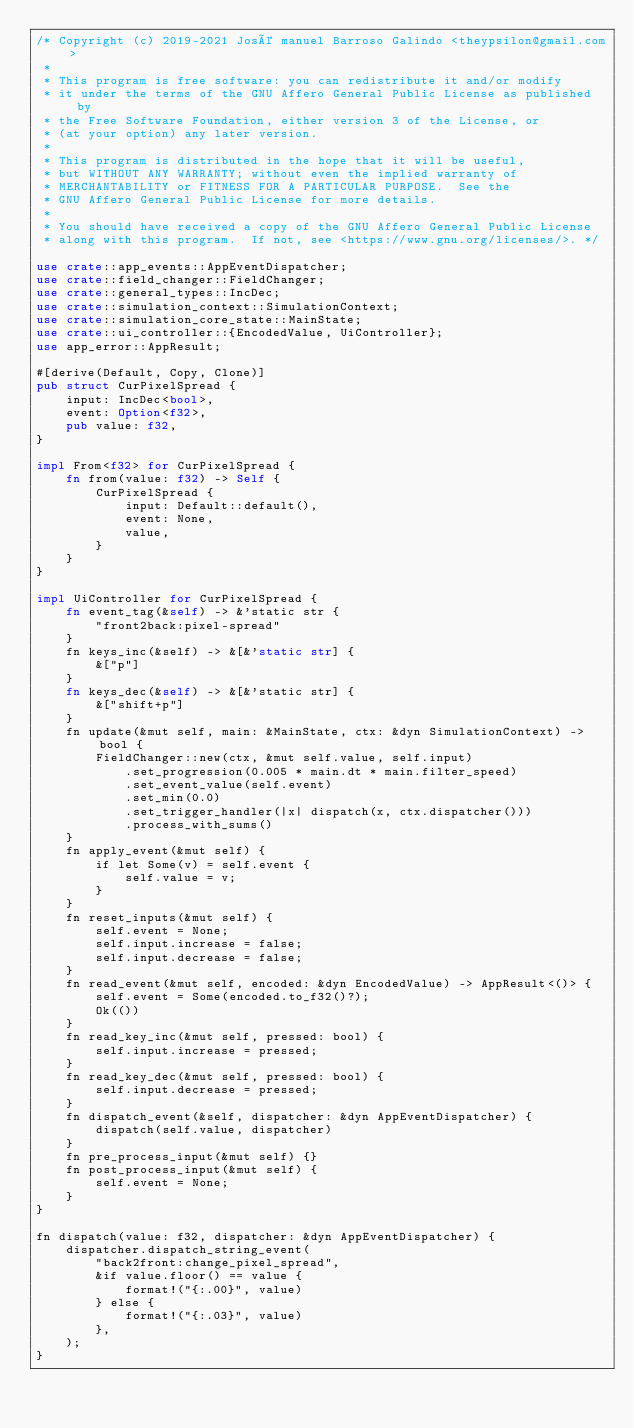Convert code to text. <code><loc_0><loc_0><loc_500><loc_500><_Rust_>/* Copyright (c) 2019-2021 José manuel Barroso Galindo <theypsilon@gmail.com>
 *
 * This program is free software: you can redistribute it and/or modify
 * it under the terms of the GNU Affero General Public License as published by
 * the Free Software Foundation, either version 3 of the License, or
 * (at your option) any later version.
 *
 * This program is distributed in the hope that it will be useful,
 * but WITHOUT ANY WARRANTY; without even the implied warranty of
 * MERCHANTABILITY or FITNESS FOR A PARTICULAR PURPOSE.  See the
 * GNU Affero General Public License for more details.
 *
 * You should have received a copy of the GNU Affero General Public License
 * along with this program.  If not, see <https://www.gnu.org/licenses/>. */

use crate::app_events::AppEventDispatcher;
use crate::field_changer::FieldChanger;
use crate::general_types::IncDec;
use crate::simulation_context::SimulationContext;
use crate::simulation_core_state::MainState;
use crate::ui_controller::{EncodedValue, UiController};
use app_error::AppResult;

#[derive(Default, Copy, Clone)]
pub struct CurPixelSpread {
    input: IncDec<bool>,
    event: Option<f32>,
    pub value: f32,
}

impl From<f32> for CurPixelSpread {
    fn from(value: f32) -> Self {
        CurPixelSpread {
            input: Default::default(),
            event: None,
            value,
        }
    }
}

impl UiController for CurPixelSpread {
    fn event_tag(&self) -> &'static str {
        "front2back:pixel-spread"
    }
    fn keys_inc(&self) -> &[&'static str] {
        &["p"]
    }
    fn keys_dec(&self) -> &[&'static str] {
        &["shift+p"]
    }
    fn update(&mut self, main: &MainState, ctx: &dyn SimulationContext) -> bool {
        FieldChanger::new(ctx, &mut self.value, self.input)
            .set_progression(0.005 * main.dt * main.filter_speed)
            .set_event_value(self.event)
            .set_min(0.0)
            .set_trigger_handler(|x| dispatch(x, ctx.dispatcher()))
            .process_with_sums()
    }
    fn apply_event(&mut self) {
        if let Some(v) = self.event {
            self.value = v;
        }
    }
    fn reset_inputs(&mut self) {
        self.event = None;
        self.input.increase = false;
        self.input.decrease = false;
    }
    fn read_event(&mut self, encoded: &dyn EncodedValue) -> AppResult<()> {
        self.event = Some(encoded.to_f32()?);
        Ok(())
    }
    fn read_key_inc(&mut self, pressed: bool) {
        self.input.increase = pressed;
    }
    fn read_key_dec(&mut self, pressed: bool) {
        self.input.decrease = pressed;
    }
    fn dispatch_event(&self, dispatcher: &dyn AppEventDispatcher) {
        dispatch(self.value, dispatcher)
    }
    fn pre_process_input(&mut self) {}
    fn post_process_input(&mut self) {
        self.event = None;
    }
}

fn dispatch(value: f32, dispatcher: &dyn AppEventDispatcher) {
    dispatcher.dispatch_string_event(
        "back2front:change_pixel_spread",
        &if value.floor() == value {
            format!("{:.00}", value)
        } else {
            format!("{:.03}", value)
        },
    );
}
</code> 